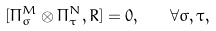Convert formula to latex. <formula><loc_0><loc_0><loc_500><loc_500>[ \Pi _ { \sigma } ^ { M } \otimes \Pi _ { \tau } ^ { N } , R ] = 0 , \quad \forall \sigma , \tau ,</formula> 